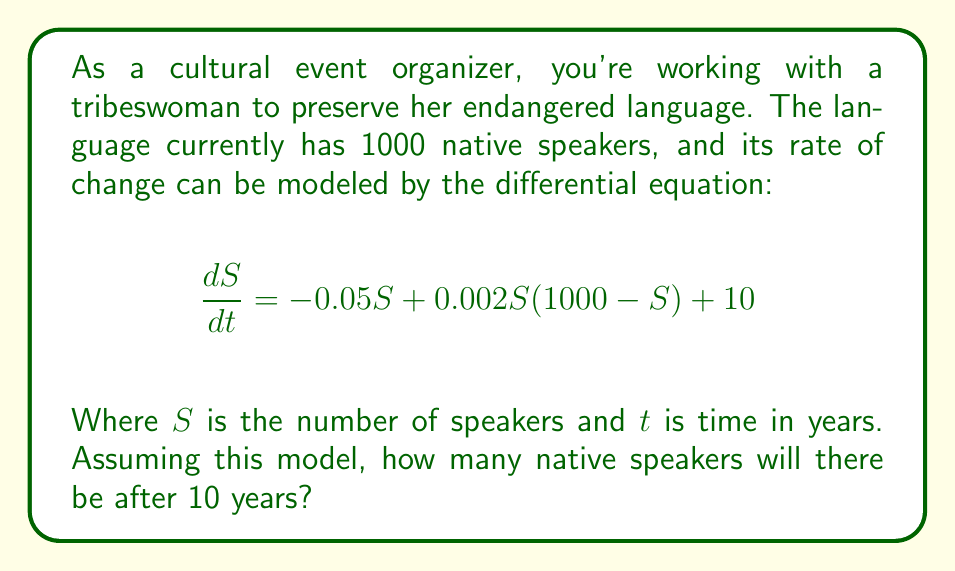What is the answer to this math problem? To solve this problem, we need to use numerical methods to approximate the solution to the differential equation, as it is nonlinear and doesn't have a straightforward analytical solution.

Let's use the Euler method with a step size of 1 year:

1) The Euler method is given by: $S_{n+1} = S_n + h \cdot f(S_n)$
   Where $h$ is the step size (1 year in this case) and $f(S)$ is the right-hand side of the differential equation.

2) $f(S) = -0.05S + 0.002S(1000-S) + 10$

3) Starting with $S_0 = 1000$, we calculate for 10 steps:

   $S_1 = 1000 + 1 \cdot (-0.05 \cdot 1000 + 0.002 \cdot 1000 \cdot (1000-1000) + 10) = 960$
   
   $S_2 = 960 + 1 \cdot (-0.05 \cdot 960 + 0.002 \cdot 960 \cdot (1000-960) + 10) = 932.16$
   
   $S_3 = 932.16 + 1 \cdot (-0.05 \cdot 932.16 + 0.002 \cdot 932.16 \cdot (1000-932.16) + 10) = 913.39$

   ...

4) Continuing this process for 7 more steps, we arrive at the final value after 10 years.

Note: In practice, we would use a smaller step size or a more sophisticated method for better accuracy, but this gives us a reasonable approximation.
Answer: After 10 years, there will be approximately 846 native speakers of the endangered language. 